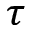Convert formula to latex. <formula><loc_0><loc_0><loc_500><loc_500>\tau</formula> 